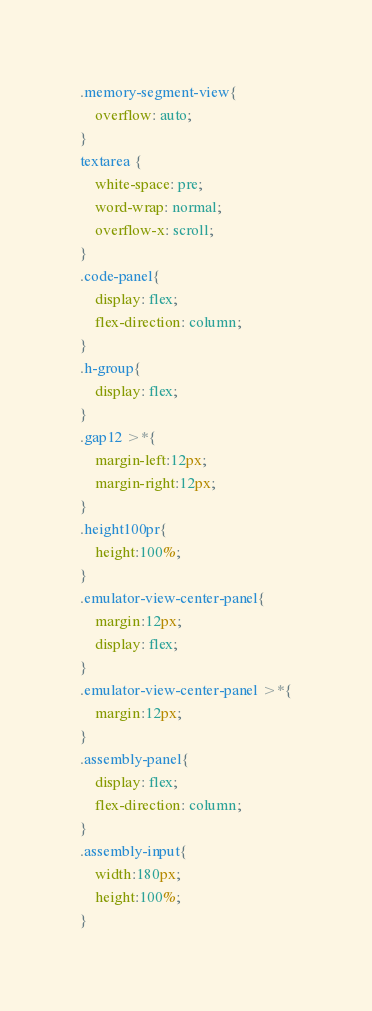<code> <loc_0><loc_0><loc_500><loc_500><_CSS_>.memory-segment-view{
    overflow: auto;
}
textarea {
    white-space: pre;
    word-wrap: normal;
    overflow-x: scroll;
}
.code-panel{
    display: flex;
    flex-direction: column;
}
.h-group{
    display: flex;
}
.gap12 >*{
    margin-left:12px;
    margin-right:12px;
}
.height100pr{
    height:100%;
}
.emulator-view-center-panel{
    margin:12px;
    display: flex;
}
.emulator-view-center-panel >*{
    margin:12px;
}
.assembly-panel{
    display: flex;
    flex-direction: column;
}
.assembly-input{
    width:180px;
    height:100%;
}</code> 